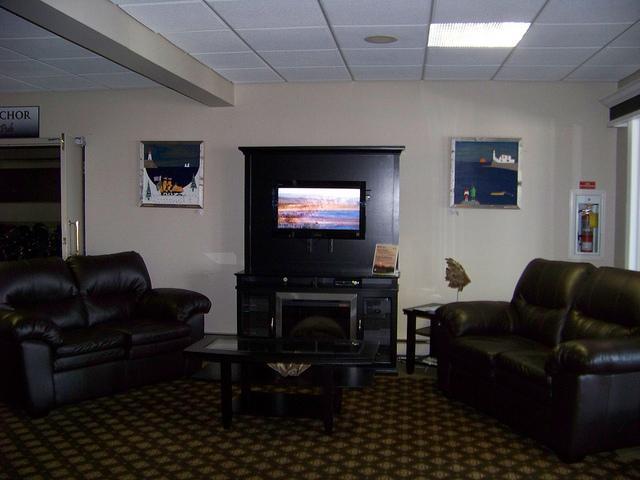How many love seat's is in the room?
Give a very brief answer. 2. How many couches are in the picture?
Give a very brief answer. 2. 